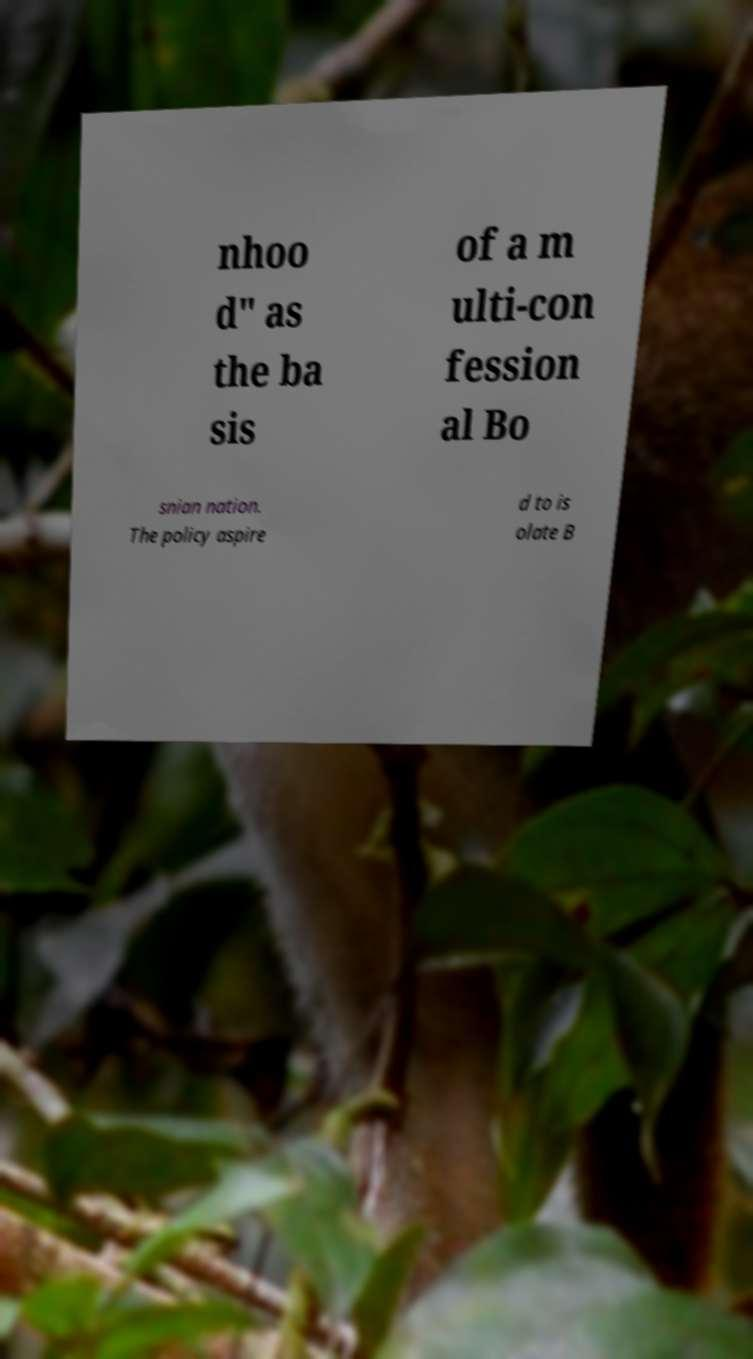What messages or text are displayed in this image? I need them in a readable, typed format. nhoo d" as the ba sis of a m ulti-con fession al Bo snian nation. The policy aspire d to is olate B 